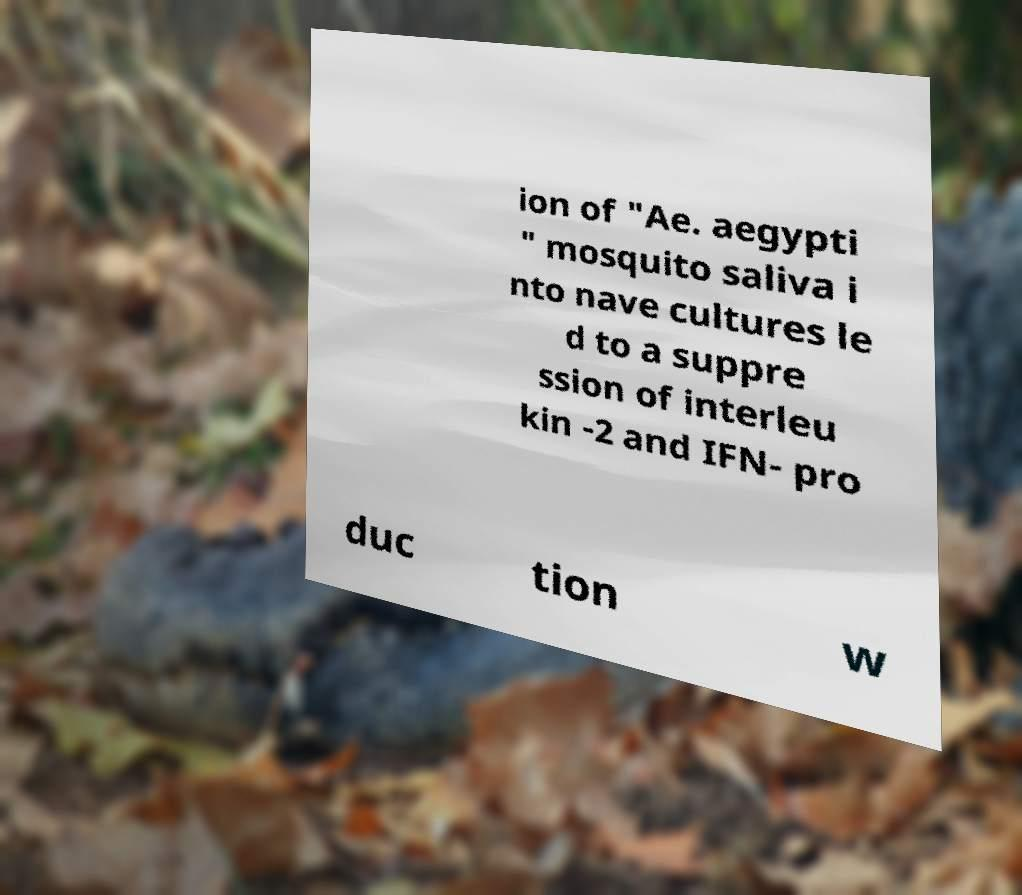There's text embedded in this image that I need extracted. Can you transcribe it verbatim? ion of "Ae. aegypti " mosquito saliva i nto nave cultures le d to a suppre ssion of interleu kin -2 and IFN- pro duc tion w 